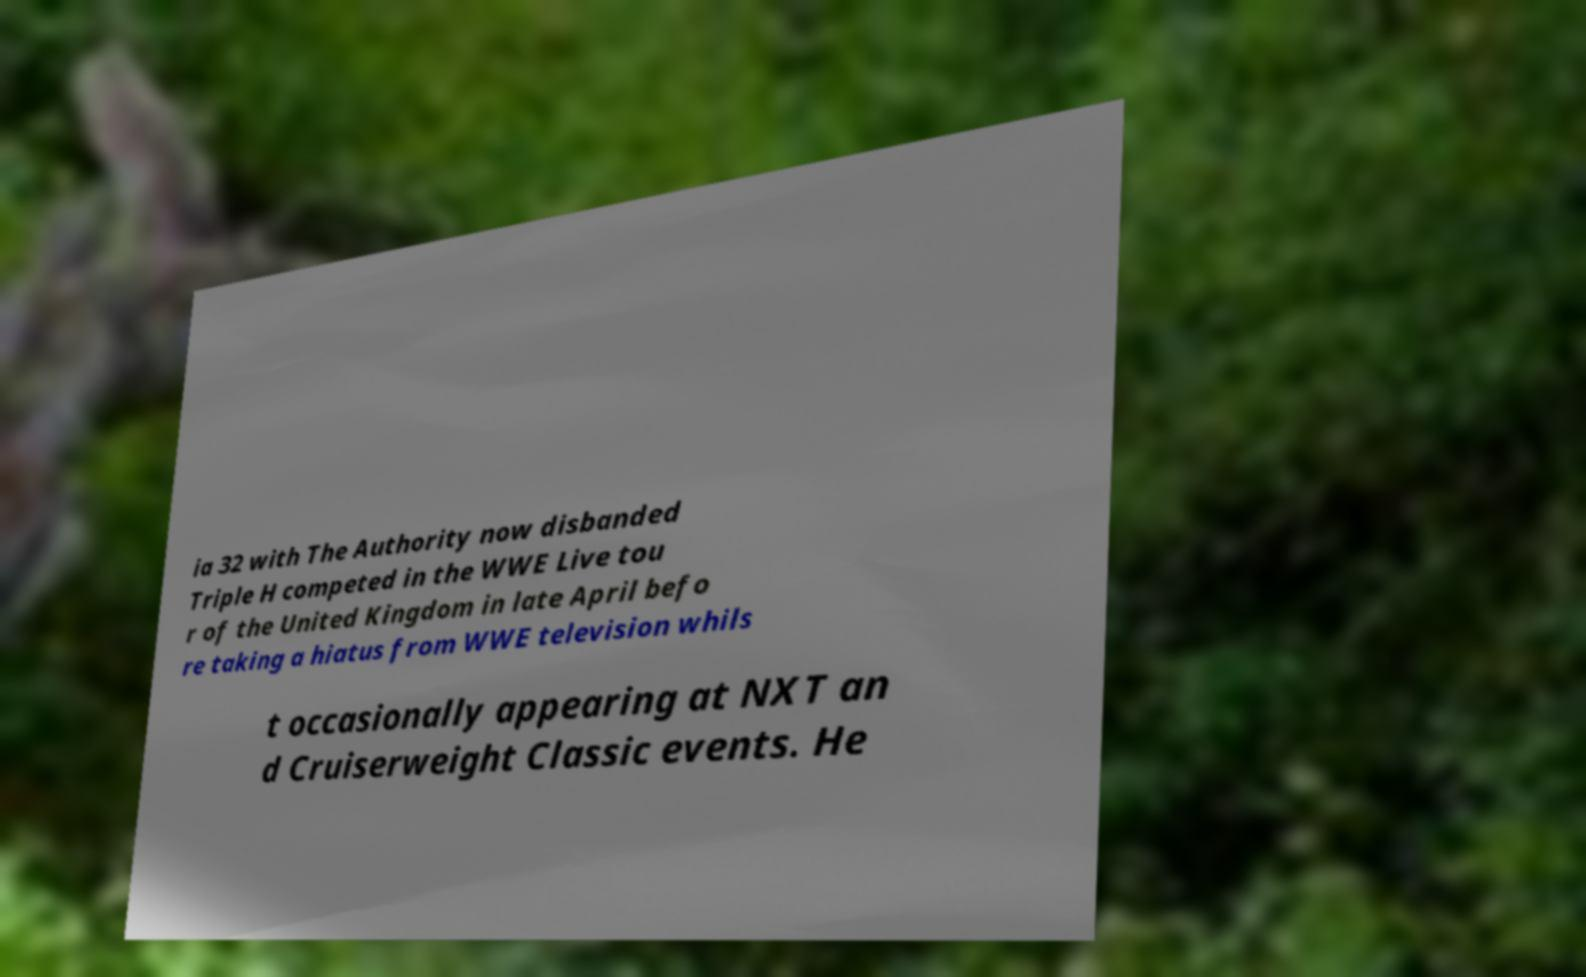Please read and relay the text visible in this image. What does it say? ia 32 with The Authority now disbanded Triple H competed in the WWE Live tou r of the United Kingdom in late April befo re taking a hiatus from WWE television whils t occasionally appearing at NXT an d Cruiserweight Classic events. He 